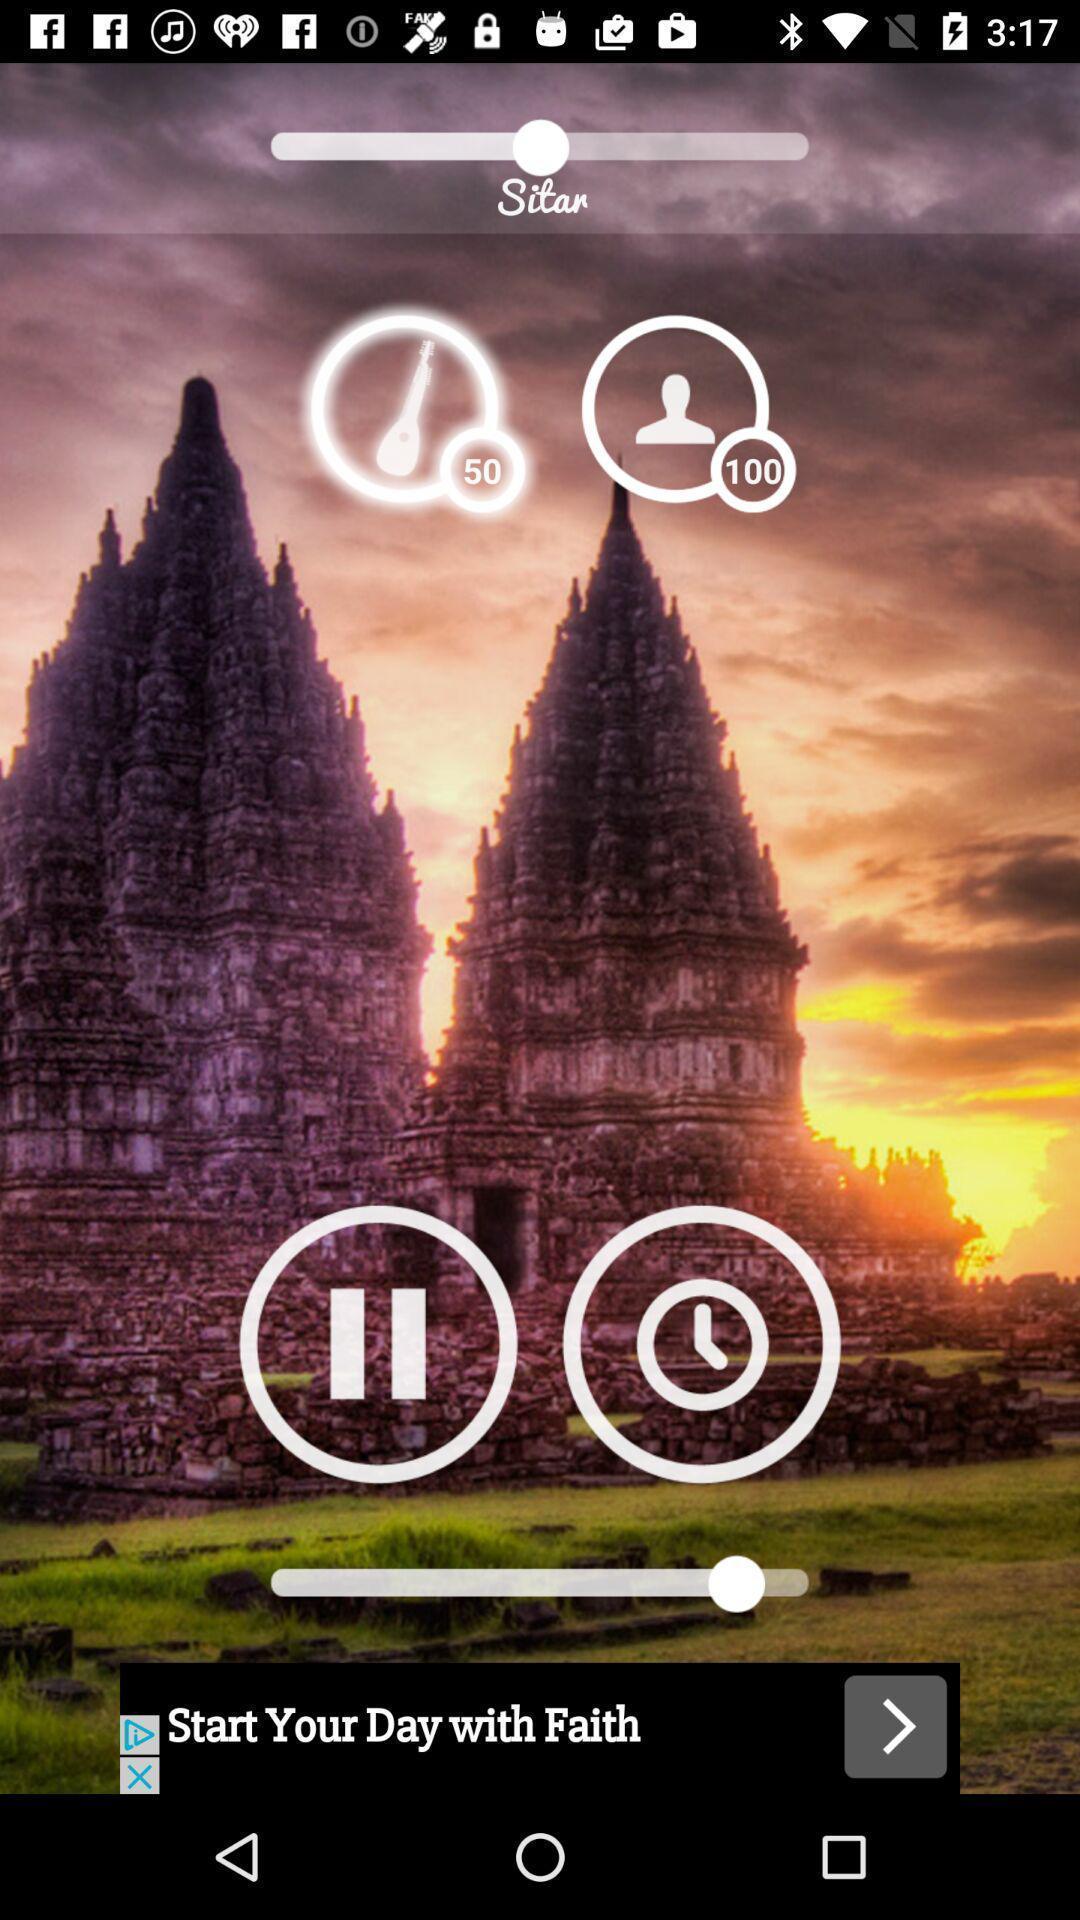Describe this image in words. Page of a music application. 